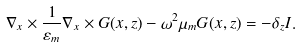Convert formula to latex. <formula><loc_0><loc_0><loc_500><loc_500>\nabla _ { x } \times \frac { 1 } { \varepsilon _ { m } } \nabla _ { x } \times { G } ( x , z ) - \omega ^ { 2 } \mu _ { m } { G } ( x , z ) = - \delta _ { z } { I } .</formula> 